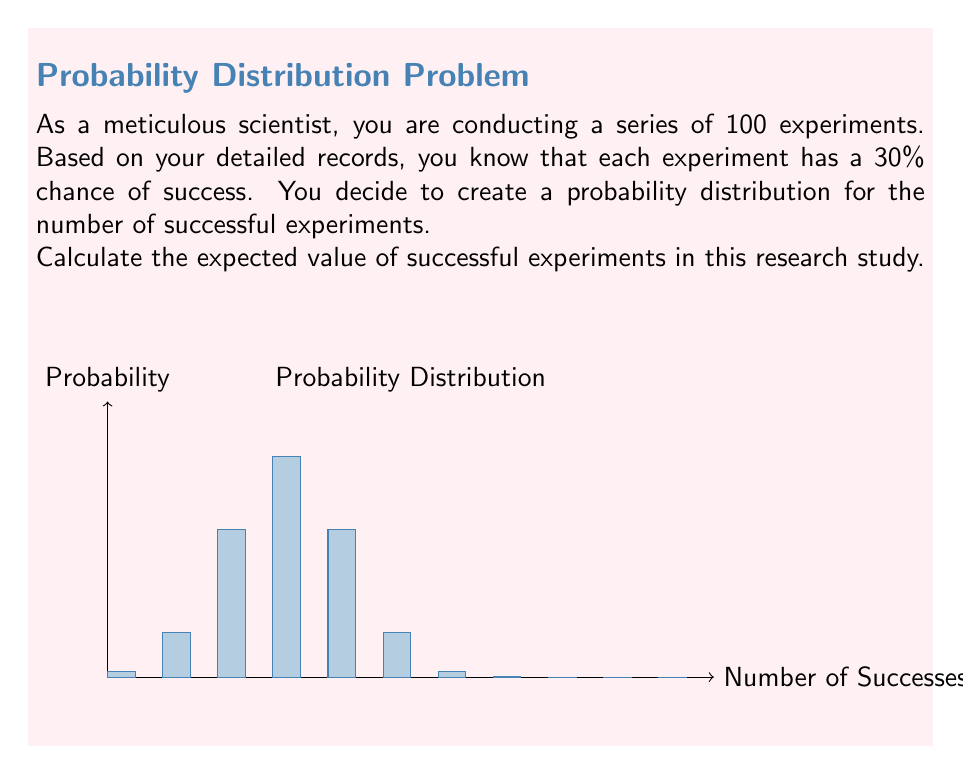Give your solution to this math problem. To calculate the expected value of successful experiments, we need to follow these steps:

1) First, recall that the expected value is calculated by multiplying each possible outcome by its probability and then summing these products.

2) In this case, we have a binomial distribution with $n=100$ trials and probability of success $p=0.3$ for each trial.

3) For a binomial distribution, the expected value is given by the formula:

   $E(X) = np$

   Where:
   $E(X)$ is the expected value
   $n$ is the number of trials
   $p$ is the probability of success for each trial

4) Substituting our values:

   $E(X) = 100 \cdot 0.3$

5) Calculating:

   $E(X) = 30$

Therefore, the expected value of successful experiments in this research study is 30.
Answer: $30$ 